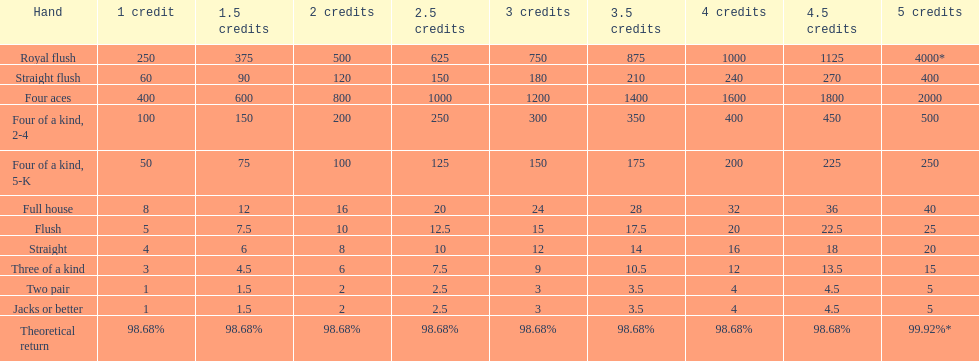Which hand is the top hand in the card game super aces? Royal flush. 